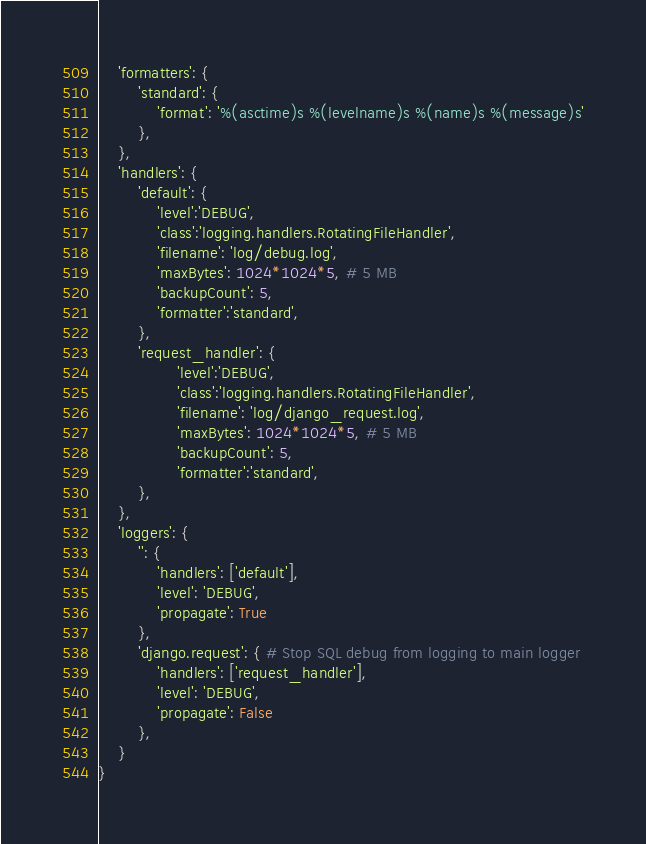<code> <loc_0><loc_0><loc_500><loc_500><_Python_>    'formatters': {
        'standard': {
            'format': '%(asctime)s %(levelname)s %(name)s %(message)s'
        },
    },
    'handlers': {
        'default': {
            'level':'DEBUG',
            'class':'logging.handlers.RotatingFileHandler',
            'filename': 'log/debug.log',
            'maxBytes': 1024*1024*5, # 5 MB
            'backupCount': 5,
            'formatter':'standard',
        },
        'request_handler': {
                'level':'DEBUG',
                'class':'logging.handlers.RotatingFileHandler',
                'filename': 'log/django_request.log',
                'maxBytes': 1024*1024*5, # 5 MB
                'backupCount': 5,
                'formatter':'standard',
        },
    },
    'loggers': {
        '': {
            'handlers': ['default'],
            'level': 'DEBUG',
            'propagate': True
        },
        'django.request': { # Stop SQL debug from logging to main logger
            'handlers': ['request_handler'],
            'level': 'DEBUG',
            'propagate': False
        },
    }
}</code> 